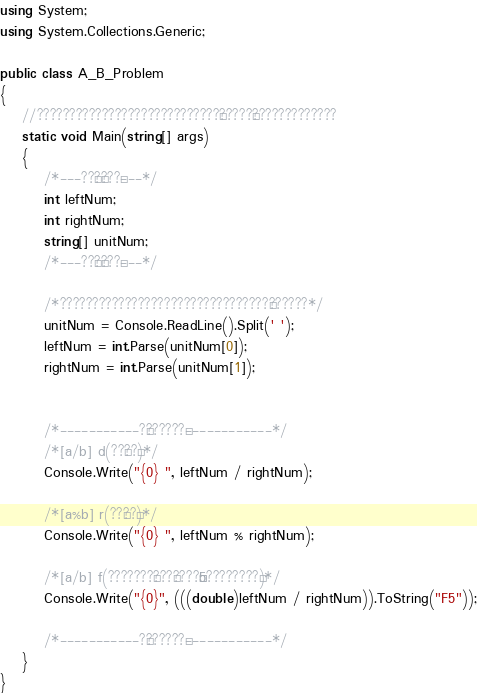Convert code to text. <code><loc_0><loc_0><loc_500><loc_500><_C#_>using System;
using System.Collections.Generic;

public class A_B_Problem
{
    //????????????????????????????¨?????¨?????????????
    static void Main(string[] args)
    {
        /*---??£?¨???¨---*/
        int leftNum;
        int rightNum;
        string[] unitNum;
        /*---??£?¨???¨---*/

        /*????????????????????????????????§??????*/
        unitNum = Console.ReadLine().Split(' ');
        leftNum = int.Parse(unitNum[0]);
        rightNum = int.Parse(unitNum[1]);


        /*-----------?¨??????¨------------*/
        /*[a/b] d(??´??°)*/
        Console.Write("{0} ", leftNum / rightNum);

        /*[a%b] r(??´??°)*/
        Console.Write("{0} ", leftNum % rightNum);

        /*[a/b] f(???????°???°????¬¬5????????§)*/
        Console.Write("{0}", (((double)leftNum / rightNum)).ToString("F5"));

        /*-----------?¨??????¨------------*/
    }
}</code> 